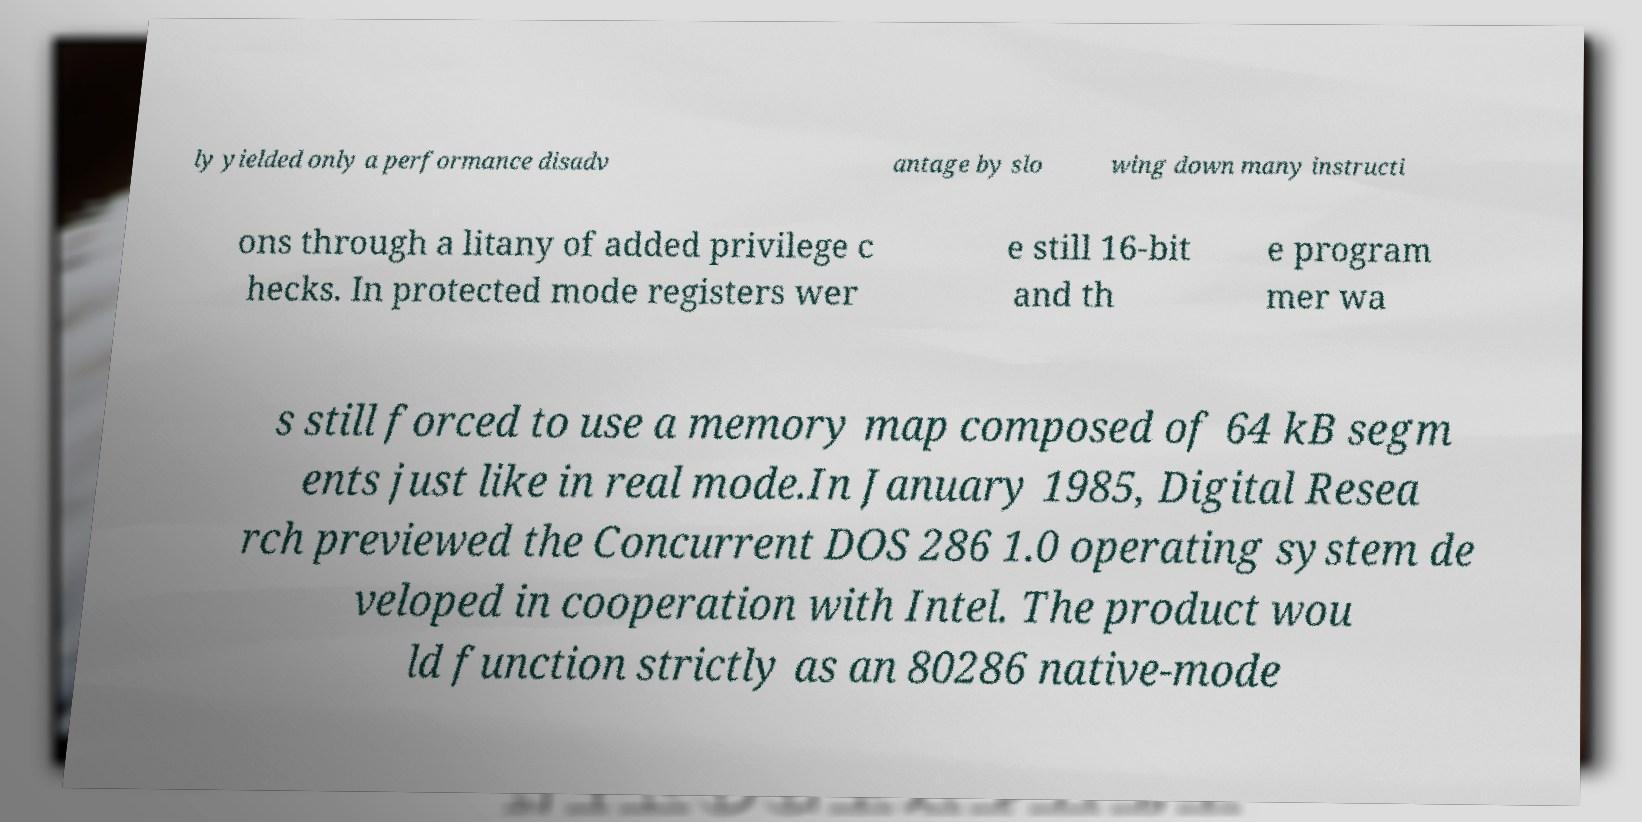Please identify and transcribe the text found in this image. ly yielded only a performance disadv antage by slo wing down many instructi ons through a litany of added privilege c hecks. In protected mode registers wer e still 16-bit and th e program mer wa s still forced to use a memory map composed of 64 kB segm ents just like in real mode.In January 1985, Digital Resea rch previewed the Concurrent DOS 286 1.0 operating system de veloped in cooperation with Intel. The product wou ld function strictly as an 80286 native-mode 